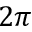<formula> <loc_0><loc_0><loc_500><loc_500>2 \pi</formula> 